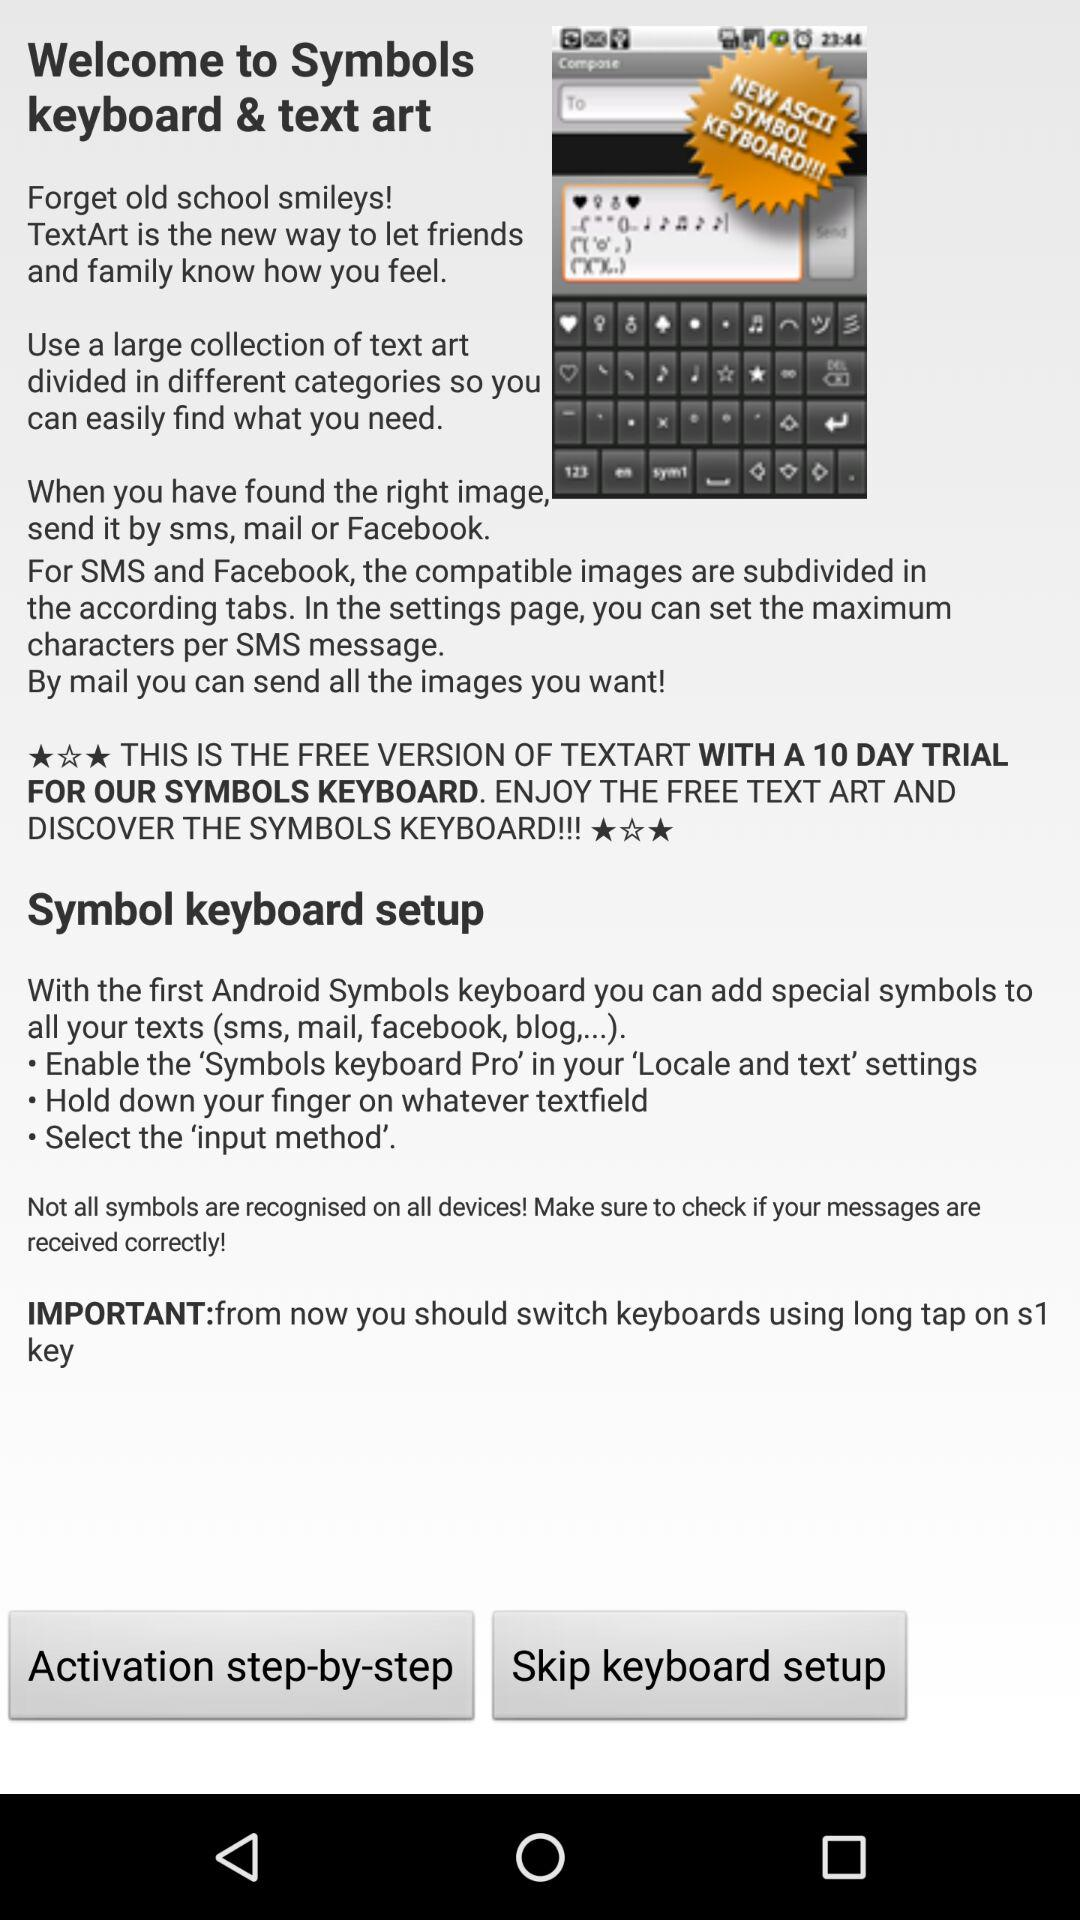Is the app version free or paid?
Answer the question using a single word or phrase. It is free. 